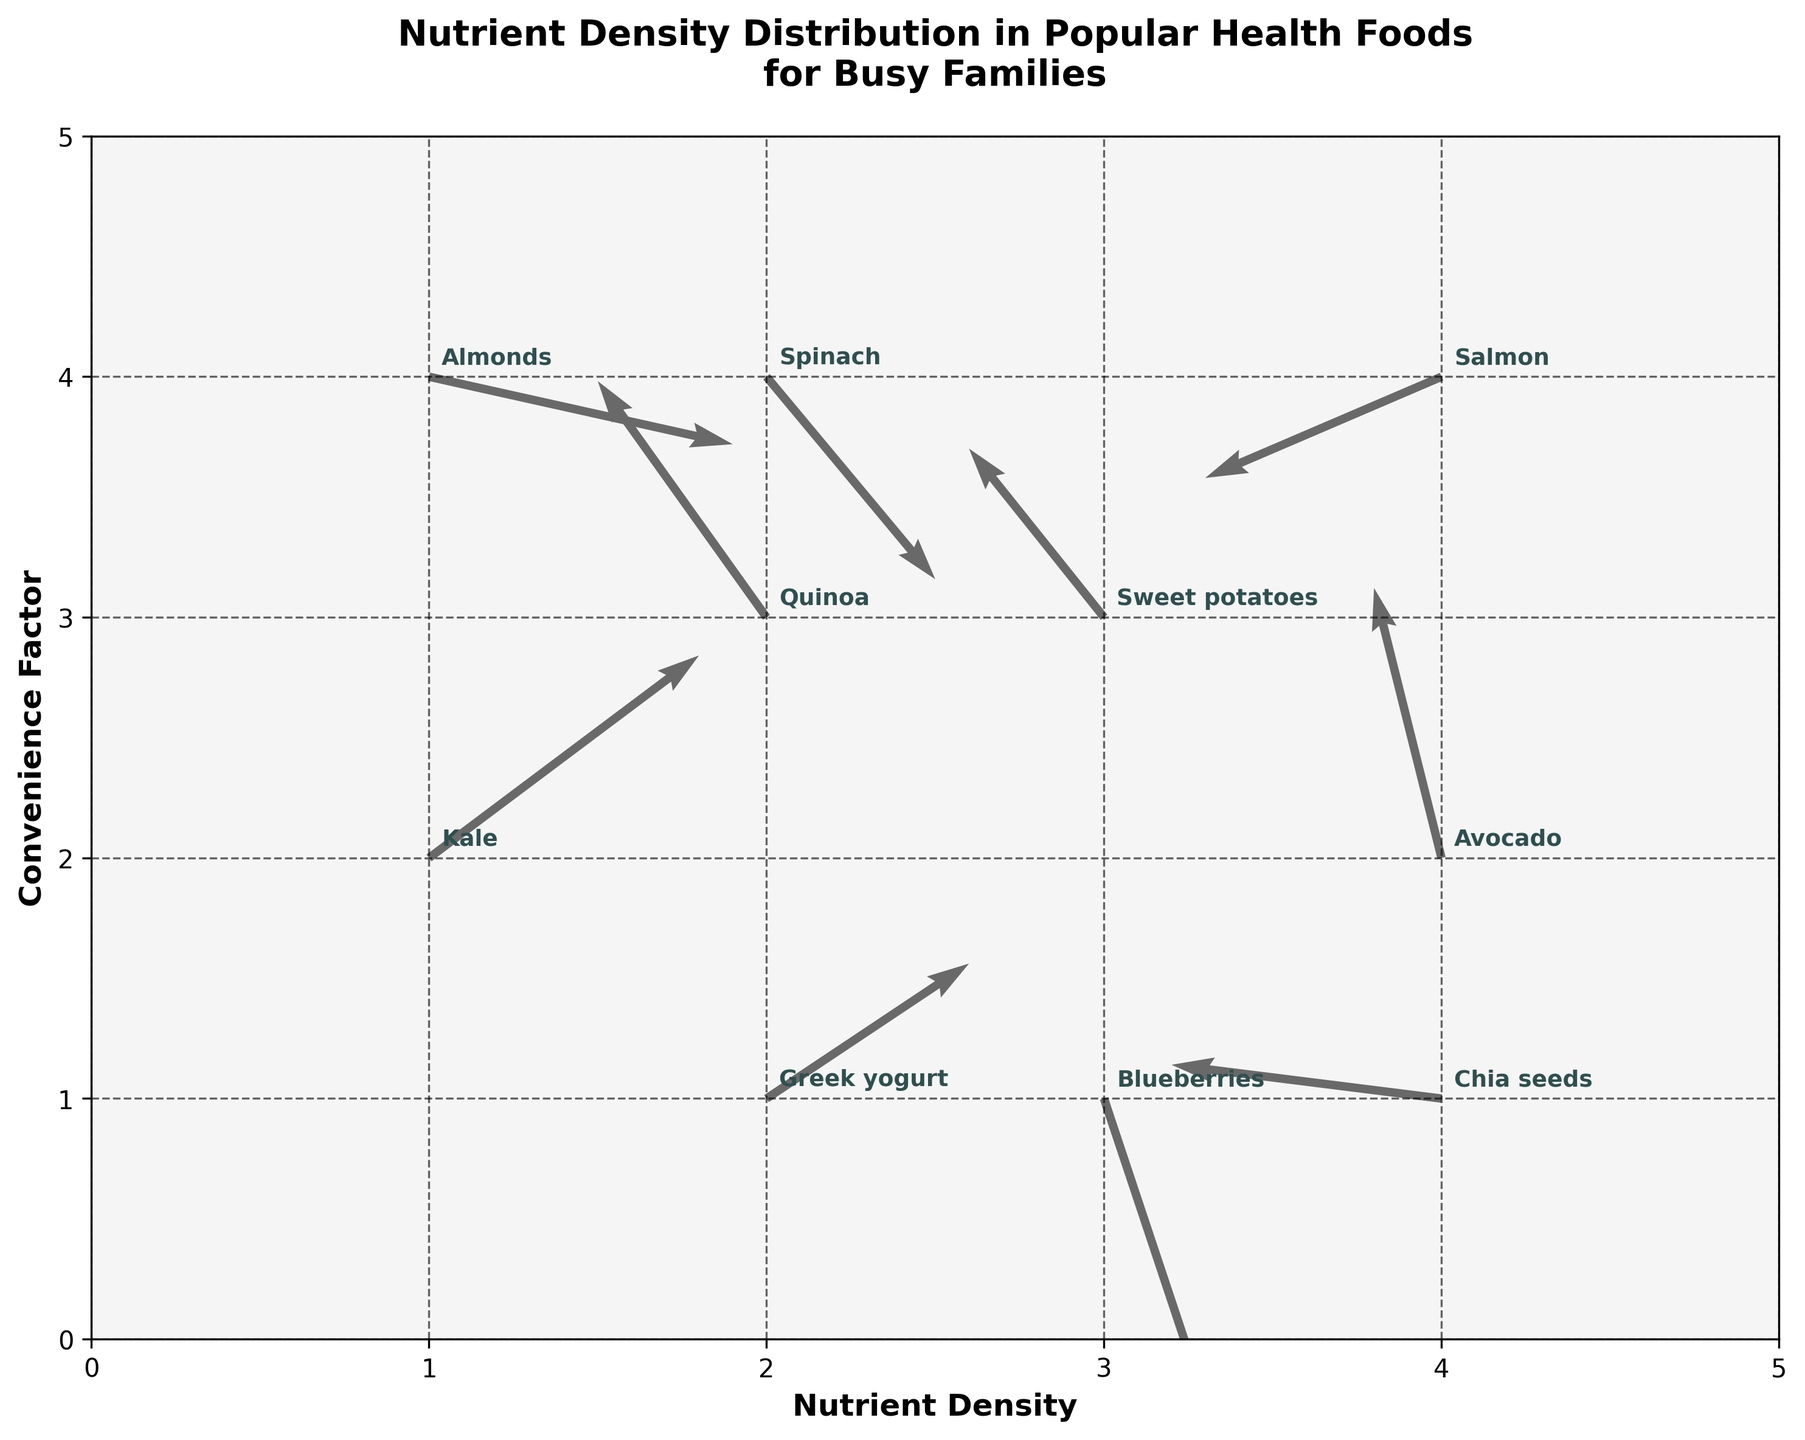What is the title of the figure? The title is prominently displayed at the top of the figure in bold text.
Answer: Nutrient Density Distribution in Popular Health Foods for Busy Families How many health foods are represented in the figure? Count the number of unique annotations within the quiver plot. Each food is labeled.
Answer: 10 Which food has the highest nutrient density? The highest nutrient density is represented by the highest x-coordinate value on the x-axis.
Answer: Almonds What are the axis labels in the figure? The labels are on the x and y axes and are written in bold text.
Answer: Nutrient Density and Convenience Factor What food shows the largest positive change in convenience factor? Examine the arrows' vertical component (v). The largest positive change is indicated by the longest upward arrow. Look for the food label near this arrow.
Answer: Avocado How many foods have a negative change in convenience factor? Identify arrows where the vertical component (v) is negative (pointing downward) and count the respective foods.
Answer: 4 Which food is more nutrient-dense, Quinoa or Greek yogurt? Compare the x-coordinates of the arrows labeled "Quinoa" and "Greek yogurt." The one with the higher x-coordinate is more nutrient-dense.
Answer: Greek yogurt Which food has the most balanced increase in both nutrient density and convenience factor? Look for the arrow with the most equal positive components for both nutrient density (u) and convenience factor (v).
Answer: Kale Which foods have both negative changes in nutrient density and convenience factor? Identify the arrows where both the horizontal component (u) and vertical component (v) are negative, and note the respective food labels.
Answer: Sweet potatoes, Salmon What visual styles and color scheme is used in the plot? Notice the overall appearance, background color, and arrow color mentioned in the title.
Answer: Grayscale theme with dimgray arrows and darkslategray text 